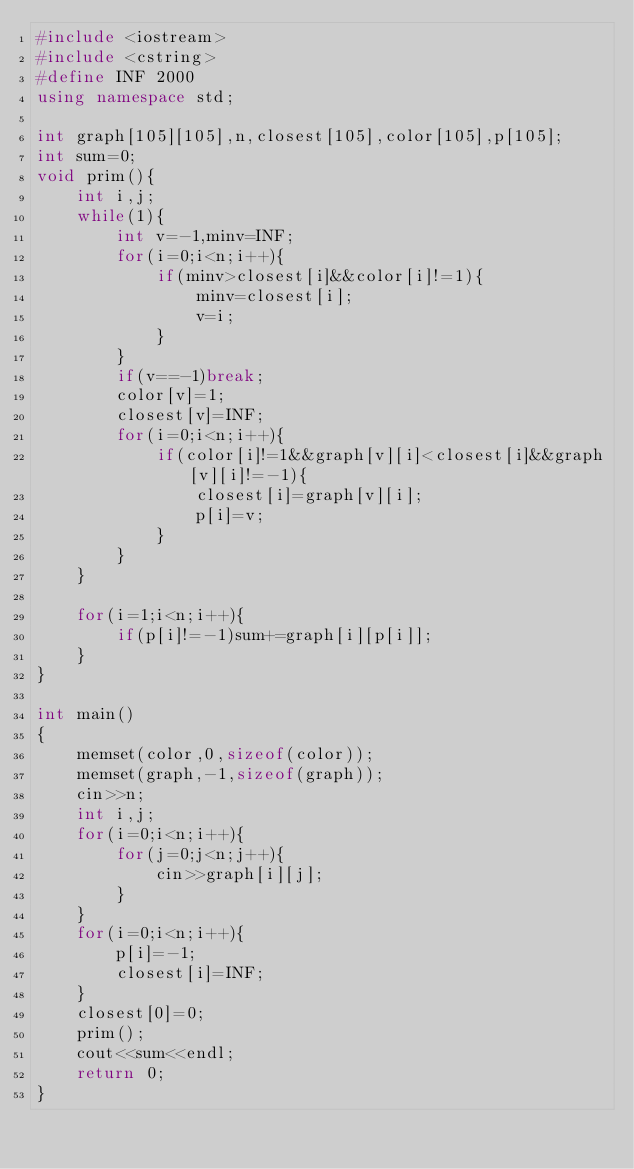Convert code to text. <code><loc_0><loc_0><loc_500><loc_500><_C++_>#include <iostream>
#include <cstring>
#define INF 2000
using namespace std;

int graph[105][105],n,closest[105],color[105],p[105];
int sum=0;
void prim(){
    int i,j;
    while(1){
        int v=-1,minv=INF;
        for(i=0;i<n;i++){
            if(minv>closest[i]&&color[i]!=1){
                minv=closest[i];
                v=i;
            }
        }
        if(v==-1)break;
        color[v]=1;
        closest[v]=INF;
        for(i=0;i<n;i++){
            if(color[i]!=1&&graph[v][i]<closest[i]&&graph[v][i]!=-1){
                closest[i]=graph[v][i];
                p[i]=v;
            }
        }
    }

    for(i=1;i<n;i++){
        if(p[i]!=-1)sum+=graph[i][p[i]];
    }
}

int main()
{
    memset(color,0,sizeof(color));
    memset(graph,-1,sizeof(graph));
    cin>>n;
    int i,j;
    for(i=0;i<n;i++){
        for(j=0;j<n;j++){
            cin>>graph[i][j];
        }
    }
    for(i=0;i<n;i++){
        p[i]=-1;
        closest[i]=INF;
    }
    closest[0]=0;
    prim();
    cout<<sum<<endl;
    return 0;
}</code> 